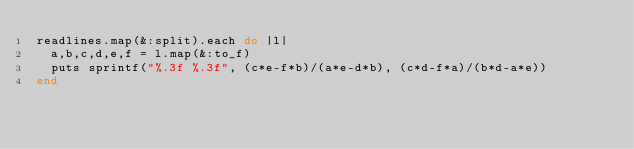<code> <loc_0><loc_0><loc_500><loc_500><_Ruby_>readlines.map(&:split).each do |l|
  a,b,c,d,e,f = l.map(&:to_f)
  puts sprintf("%.3f %.3f", (c*e-f*b)/(a*e-d*b), (c*d-f*a)/(b*d-a*e))
end</code> 